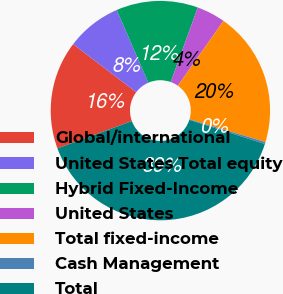<chart> <loc_0><loc_0><loc_500><loc_500><pie_chart><fcel>Global/international<fcel>United States Total equity<fcel>Hybrid Fixed-Income<fcel>United States<fcel>Total fixed-income<fcel>Cash Management<fcel>Total<nl><fcel>15.96%<fcel>8.13%<fcel>12.05%<fcel>4.21%<fcel>19.88%<fcel>0.29%<fcel>39.47%<nl></chart> 